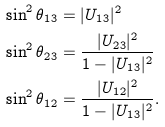<formula> <loc_0><loc_0><loc_500><loc_500>\sin ^ { 2 } \theta _ { 1 3 } & = | U _ { 1 3 } | ^ { 2 } \\ \sin ^ { 2 } \theta _ { 2 3 } & = \frac { | U _ { 2 3 } | ^ { 2 } } { 1 - | U _ { 1 3 } | ^ { 2 } } \\ \sin ^ { 2 } \theta _ { 1 2 } & = \frac { | U _ { 1 2 } | ^ { 2 } } { { 1 - | U _ { 1 3 } | ^ { 2 } } } .</formula> 